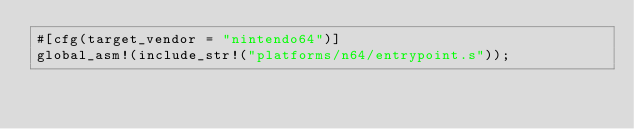Convert code to text. <code><loc_0><loc_0><loc_500><loc_500><_Rust_>#[cfg(target_vendor = "nintendo64")]
global_asm!(include_str!("platforms/n64/entrypoint.s"));
</code> 